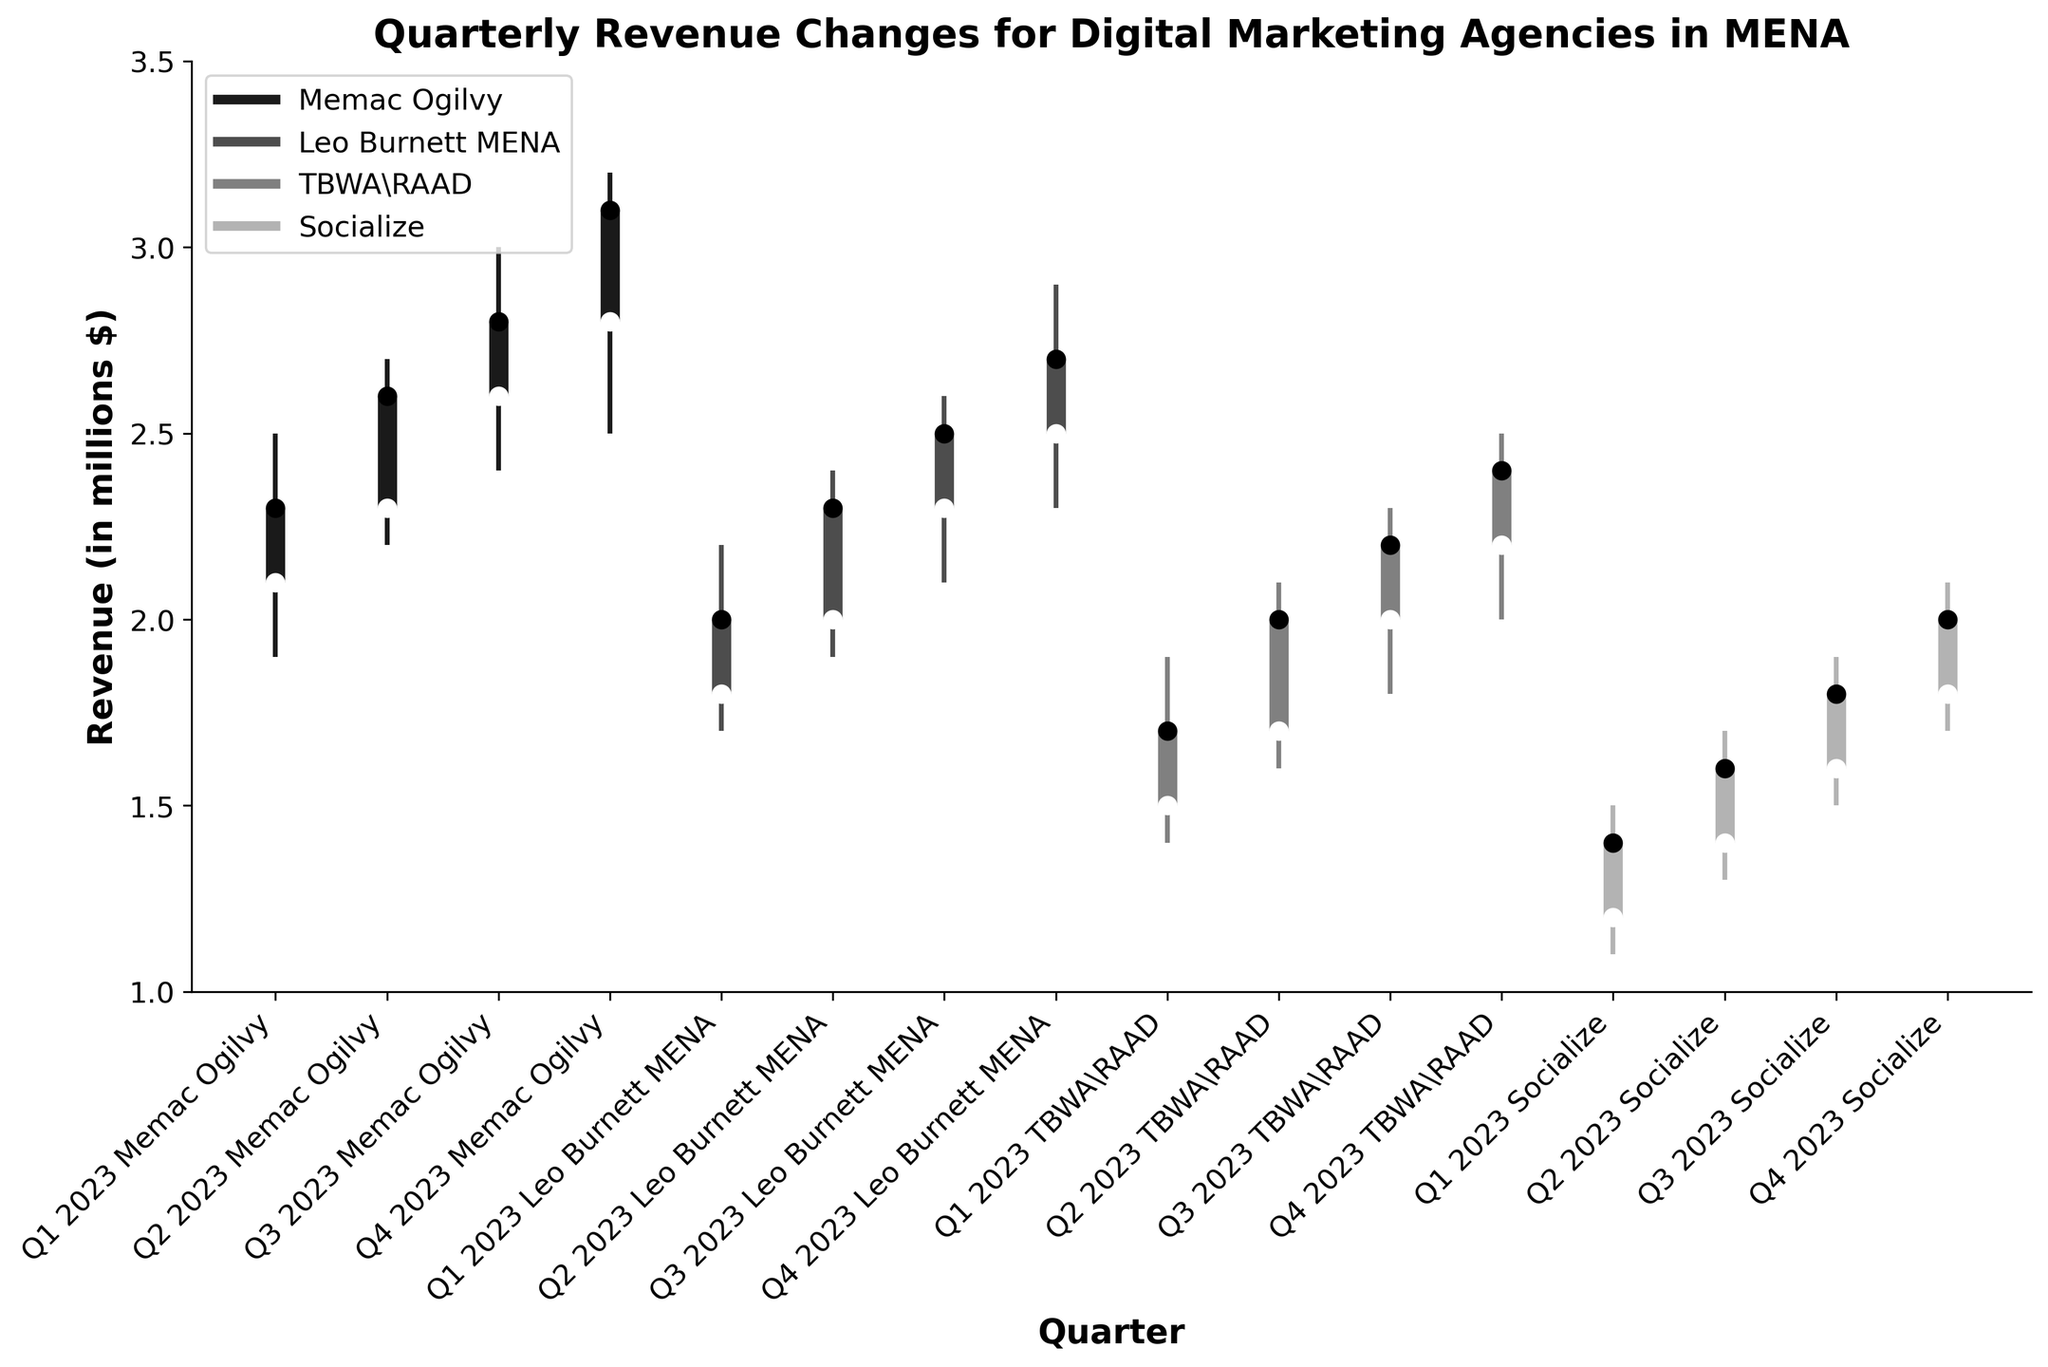What is the title of the figure? The title is usually located at the top of the figure. Here, it states the main topic of the plot.
Answer: Quarterly Revenue Changes for Digital Marketing Agencies in MENA Which agency had the highest closing revenue in Q4 2023? To find the highest closing revenue, look at the 'Close' values for Q4 2023 and compare them across all agencies.
Answer: Memac Ogilvy How much did Leo Burnett MENA's revenue increase from Q1 to Q2 in 2023? Compare the 'Close' values for Leo Burnett MENA from Q1 and Q2 2023. The increase is calculated as the difference between these values.
Answer: 0.3 million $ Which agency showed the most significant change between its highest and lowest revenue in any quarter? We need to find the maximum difference between 'High' and 'Low' for each agency across all quarters and compare them.
Answer: Memac Ogilvy What is the average closing revenue of Socialize in 2023? Sum the 'Close' values for Socialize across all quarters in 2023, then divide by the number of quarters (4).
Answer: 1.7 million $ Between Q2 and Q3 2023, which agency had the highest increase in closing revenue? Calculate the difference in 'Close' values between Q2 and Q3 for all agencies and compare to find the highest increase.
Answer: TBWA\RAAD Which quarter shows the highest opening revenue for Memac Ogilvy? Look at the 'Open' values for Memac Ogilvy across all quarters and identify the highest.
Answer: Q4 2023 Compare the 'High' values of TBWA\RAAD and Socialize in Q4 2023. Which one is higher? Compare the 'High' points of TBWA\RAAD and Socialize specifically in Q4 2023.
Answer: TBWA\RAAD How consistent is the closing revenue trend for Leo Burnett MENA throughout 2023? Examine the 'Close' values for Leo Burnett MENA across all quarters and evaluate how much they vary.
Answer: Consistently increasing What is the range (difference between highest and lowest points) of Memac Ogilvy's revenue in Q2 2023? Calculate the difference between the 'High' and 'Low' values for Memac Ogilvy in Q2 2023.
Answer: 0.5 million $ 